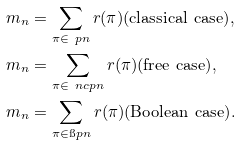<formula> <loc_0><loc_0><loc_500><loc_500>& m _ { n } = \sum _ { \pi \in \ p n } r ( \pi ) \text {(classical case)} , \\ & m _ { n } = \sum _ { \pi \in \ n c p n } r ( \pi ) \text {(free case)} , \\ & m _ { n } = \sum _ { \pi \in \i p n } r ( \pi ) \text {(Boolean case)} .</formula> 